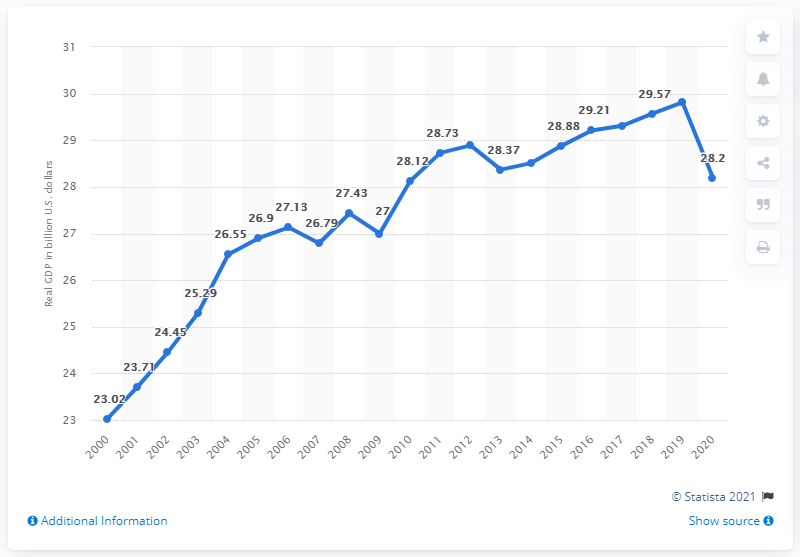Specify some key components in this picture. In 2020, the gross domestic product (GDP) of Vermont was $28.2 billion in current dollars. 